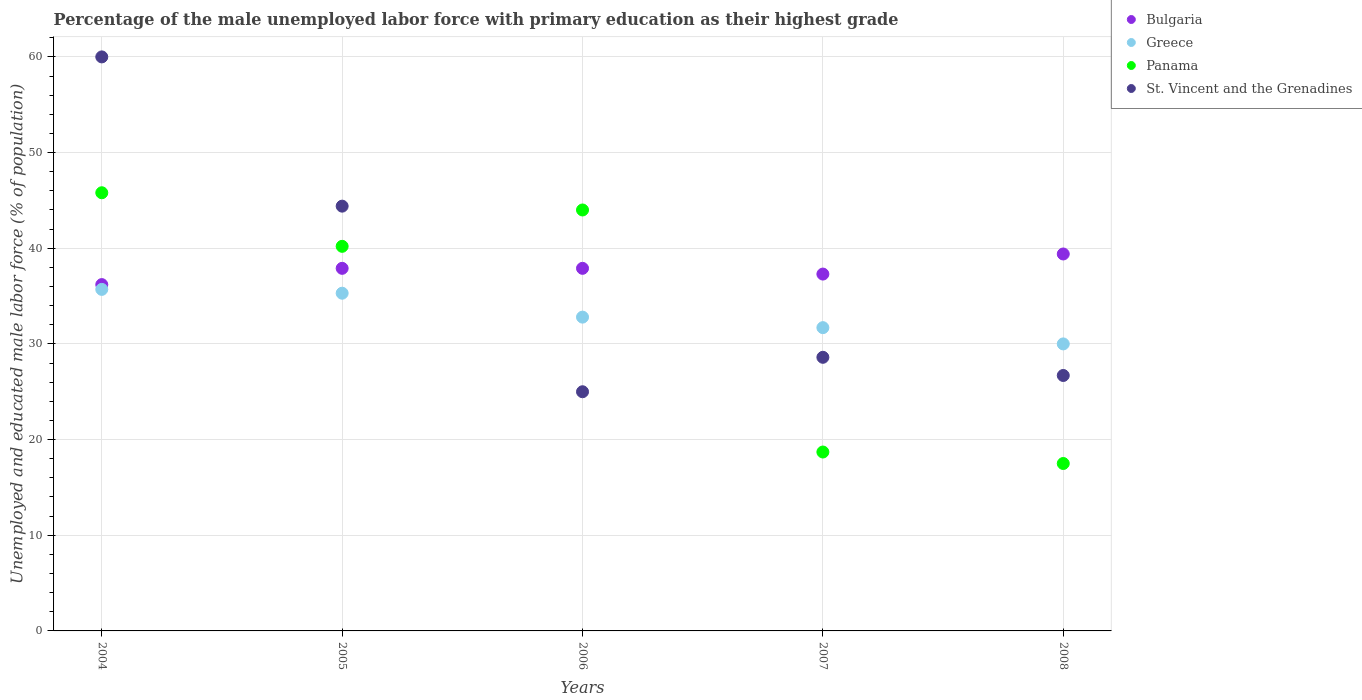How many different coloured dotlines are there?
Your answer should be very brief. 4. Is the number of dotlines equal to the number of legend labels?
Your answer should be compact. Yes. What is the percentage of the unemployed male labor force with primary education in Greece in 2006?
Your answer should be compact. 32.8. Across all years, what is the maximum percentage of the unemployed male labor force with primary education in Panama?
Provide a succinct answer. 45.8. Across all years, what is the minimum percentage of the unemployed male labor force with primary education in St. Vincent and the Grenadines?
Offer a terse response. 25. In which year was the percentage of the unemployed male labor force with primary education in Greece maximum?
Provide a short and direct response. 2004. In which year was the percentage of the unemployed male labor force with primary education in Greece minimum?
Make the answer very short. 2008. What is the total percentage of the unemployed male labor force with primary education in Greece in the graph?
Your answer should be compact. 165.5. What is the difference between the percentage of the unemployed male labor force with primary education in Panama in 2005 and that in 2006?
Give a very brief answer. -3.8. What is the average percentage of the unemployed male labor force with primary education in Greece per year?
Provide a succinct answer. 33.1. In the year 2007, what is the difference between the percentage of the unemployed male labor force with primary education in Bulgaria and percentage of the unemployed male labor force with primary education in Panama?
Provide a succinct answer. 18.6. What is the ratio of the percentage of the unemployed male labor force with primary education in Panama in 2006 to that in 2007?
Ensure brevity in your answer.  2.35. Is the percentage of the unemployed male labor force with primary education in Greece in 2004 less than that in 2005?
Keep it short and to the point. No. What is the difference between the highest and the second highest percentage of the unemployed male labor force with primary education in St. Vincent and the Grenadines?
Provide a short and direct response. 15.6. What is the difference between the highest and the lowest percentage of the unemployed male labor force with primary education in Panama?
Make the answer very short. 28.3. Is it the case that in every year, the sum of the percentage of the unemployed male labor force with primary education in Greece and percentage of the unemployed male labor force with primary education in St. Vincent and the Grenadines  is greater than the sum of percentage of the unemployed male labor force with primary education in Bulgaria and percentage of the unemployed male labor force with primary education in Panama?
Make the answer very short. No. Is the percentage of the unemployed male labor force with primary education in Bulgaria strictly less than the percentage of the unemployed male labor force with primary education in Greece over the years?
Keep it short and to the point. No. How many dotlines are there?
Make the answer very short. 4. How many years are there in the graph?
Keep it short and to the point. 5. Are the values on the major ticks of Y-axis written in scientific E-notation?
Offer a very short reply. No. Where does the legend appear in the graph?
Provide a succinct answer. Top right. How are the legend labels stacked?
Provide a short and direct response. Vertical. What is the title of the graph?
Make the answer very short. Percentage of the male unemployed labor force with primary education as their highest grade. Does "Togo" appear as one of the legend labels in the graph?
Your answer should be very brief. No. What is the label or title of the Y-axis?
Your response must be concise. Unemployed and educated male labor force (% of population). What is the Unemployed and educated male labor force (% of population) in Bulgaria in 2004?
Provide a short and direct response. 36.2. What is the Unemployed and educated male labor force (% of population) in Greece in 2004?
Your answer should be compact. 35.7. What is the Unemployed and educated male labor force (% of population) in Panama in 2004?
Make the answer very short. 45.8. What is the Unemployed and educated male labor force (% of population) in St. Vincent and the Grenadines in 2004?
Give a very brief answer. 60. What is the Unemployed and educated male labor force (% of population) in Bulgaria in 2005?
Your answer should be very brief. 37.9. What is the Unemployed and educated male labor force (% of population) of Greece in 2005?
Ensure brevity in your answer.  35.3. What is the Unemployed and educated male labor force (% of population) of Panama in 2005?
Your answer should be very brief. 40.2. What is the Unemployed and educated male labor force (% of population) in St. Vincent and the Grenadines in 2005?
Keep it short and to the point. 44.4. What is the Unemployed and educated male labor force (% of population) in Bulgaria in 2006?
Offer a very short reply. 37.9. What is the Unemployed and educated male labor force (% of population) of Greece in 2006?
Provide a short and direct response. 32.8. What is the Unemployed and educated male labor force (% of population) in Panama in 2006?
Offer a terse response. 44. What is the Unemployed and educated male labor force (% of population) in St. Vincent and the Grenadines in 2006?
Ensure brevity in your answer.  25. What is the Unemployed and educated male labor force (% of population) of Bulgaria in 2007?
Keep it short and to the point. 37.3. What is the Unemployed and educated male labor force (% of population) of Greece in 2007?
Make the answer very short. 31.7. What is the Unemployed and educated male labor force (% of population) in Panama in 2007?
Offer a very short reply. 18.7. What is the Unemployed and educated male labor force (% of population) of St. Vincent and the Grenadines in 2007?
Ensure brevity in your answer.  28.6. What is the Unemployed and educated male labor force (% of population) of Bulgaria in 2008?
Provide a succinct answer. 39.4. What is the Unemployed and educated male labor force (% of population) of Greece in 2008?
Offer a terse response. 30. What is the Unemployed and educated male labor force (% of population) of St. Vincent and the Grenadines in 2008?
Make the answer very short. 26.7. Across all years, what is the maximum Unemployed and educated male labor force (% of population) in Bulgaria?
Provide a short and direct response. 39.4. Across all years, what is the maximum Unemployed and educated male labor force (% of population) of Greece?
Make the answer very short. 35.7. Across all years, what is the maximum Unemployed and educated male labor force (% of population) in Panama?
Offer a terse response. 45.8. Across all years, what is the minimum Unemployed and educated male labor force (% of population) of Bulgaria?
Offer a terse response. 36.2. What is the total Unemployed and educated male labor force (% of population) in Bulgaria in the graph?
Provide a short and direct response. 188.7. What is the total Unemployed and educated male labor force (% of population) in Greece in the graph?
Your response must be concise. 165.5. What is the total Unemployed and educated male labor force (% of population) of Panama in the graph?
Make the answer very short. 166.2. What is the total Unemployed and educated male labor force (% of population) in St. Vincent and the Grenadines in the graph?
Keep it short and to the point. 184.7. What is the difference between the Unemployed and educated male labor force (% of population) in Bulgaria in 2004 and that in 2005?
Offer a terse response. -1.7. What is the difference between the Unemployed and educated male labor force (% of population) in Panama in 2004 and that in 2005?
Offer a very short reply. 5.6. What is the difference between the Unemployed and educated male labor force (% of population) of St. Vincent and the Grenadines in 2004 and that in 2005?
Ensure brevity in your answer.  15.6. What is the difference between the Unemployed and educated male labor force (% of population) of Bulgaria in 2004 and that in 2006?
Keep it short and to the point. -1.7. What is the difference between the Unemployed and educated male labor force (% of population) of Greece in 2004 and that in 2006?
Make the answer very short. 2.9. What is the difference between the Unemployed and educated male labor force (% of population) of Panama in 2004 and that in 2006?
Provide a succinct answer. 1.8. What is the difference between the Unemployed and educated male labor force (% of population) in St. Vincent and the Grenadines in 2004 and that in 2006?
Make the answer very short. 35. What is the difference between the Unemployed and educated male labor force (% of population) of Bulgaria in 2004 and that in 2007?
Make the answer very short. -1.1. What is the difference between the Unemployed and educated male labor force (% of population) of Panama in 2004 and that in 2007?
Your response must be concise. 27.1. What is the difference between the Unemployed and educated male labor force (% of population) of St. Vincent and the Grenadines in 2004 and that in 2007?
Give a very brief answer. 31.4. What is the difference between the Unemployed and educated male labor force (% of population) of Bulgaria in 2004 and that in 2008?
Make the answer very short. -3.2. What is the difference between the Unemployed and educated male labor force (% of population) in Panama in 2004 and that in 2008?
Your answer should be very brief. 28.3. What is the difference between the Unemployed and educated male labor force (% of population) in St. Vincent and the Grenadines in 2004 and that in 2008?
Provide a succinct answer. 33.3. What is the difference between the Unemployed and educated male labor force (% of population) in Bulgaria in 2005 and that in 2006?
Your response must be concise. 0. What is the difference between the Unemployed and educated male labor force (% of population) of Greece in 2005 and that in 2006?
Offer a terse response. 2.5. What is the difference between the Unemployed and educated male labor force (% of population) in Panama in 2005 and that in 2006?
Offer a terse response. -3.8. What is the difference between the Unemployed and educated male labor force (% of population) of St. Vincent and the Grenadines in 2005 and that in 2006?
Your response must be concise. 19.4. What is the difference between the Unemployed and educated male labor force (% of population) in Bulgaria in 2005 and that in 2007?
Provide a succinct answer. 0.6. What is the difference between the Unemployed and educated male labor force (% of population) of Greece in 2005 and that in 2007?
Your answer should be very brief. 3.6. What is the difference between the Unemployed and educated male labor force (% of population) in St. Vincent and the Grenadines in 2005 and that in 2007?
Keep it short and to the point. 15.8. What is the difference between the Unemployed and educated male labor force (% of population) of Greece in 2005 and that in 2008?
Provide a short and direct response. 5.3. What is the difference between the Unemployed and educated male labor force (% of population) of Panama in 2005 and that in 2008?
Offer a very short reply. 22.7. What is the difference between the Unemployed and educated male labor force (% of population) in Greece in 2006 and that in 2007?
Your response must be concise. 1.1. What is the difference between the Unemployed and educated male labor force (% of population) in Panama in 2006 and that in 2007?
Your answer should be compact. 25.3. What is the difference between the Unemployed and educated male labor force (% of population) of St. Vincent and the Grenadines in 2006 and that in 2008?
Your response must be concise. -1.7. What is the difference between the Unemployed and educated male labor force (% of population) of Bulgaria in 2007 and that in 2008?
Offer a very short reply. -2.1. What is the difference between the Unemployed and educated male labor force (% of population) of Greece in 2007 and that in 2008?
Offer a terse response. 1.7. What is the difference between the Unemployed and educated male labor force (% of population) of St. Vincent and the Grenadines in 2007 and that in 2008?
Make the answer very short. 1.9. What is the difference between the Unemployed and educated male labor force (% of population) in Bulgaria in 2004 and the Unemployed and educated male labor force (% of population) in Panama in 2005?
Give a very brief answer. -4. What is the difference between the Unemployed and educated male labor force (% of population) in Panama in 2004 and the Unemployed and educated male labor force (% of population) in St. Vincent and the Grenadines in 2005?
Your answer should be very brief. 1.4. What is the difference between the Unemployed and educated male labor force (% of population) in Bulgaria in 2004 and the Unemployed and educated male labor force (% of population) in Greece in 2006?
Your answer should be compact. 3.4. What is the difference between the Unemployed and educated male labor force (% of population) of Bulgaria in 2004 and the Unemployed and educated male labor force (% of population) of Panama in 2006?
Your response must be concise. -7.8. What is the difference between the Unemployed and educated male labor force (% of population) in Greece in 2004 and the Unemployed and educated male labor force (% of population) in St. Vincent and the Grenadines in 2006?
Keep it short and to the point. 10.7. What is the difference between the Unemployed and educated male labor force (% of population) of Panama in 2004 and the Unemployed and educated male labor force (% of population) of St. Vincent and the Grenadines in 2006?
Provide a short and direct response. 20.8. What is the difference between the Unemployed and educated male labor force (% of population) in Bulgaria in 2004 and the Unemployed and educated male labor force (% of population) in Greece in 2007?
Offer a terse response. 4.5. What is the difference between the Unemployed and educated male labor force (% of population) in Bulgaria in 2004 and the Unemployed and educated male labor force (% of population) in Panama in 2007?
Give a very brief answer. 17.5. What is the difference between the Unemployed and educated male labor force (% of population) of Greece in 2004 and the Unemployed and educated male labor force (% of population) of St. Vincent and the Grenadines in 2007?
Provide a short and direct response. 7.1. What is the difference between the Unemployed and educated male labor force (% of population) in Panama in 2004 and the Unemployed and educated male labor force (% of population) in St. Vincent and the Grenadines in 2007?
Provide a short and direct response. 17.2. What is the difference between the Unemployed and educated male labor force (% of population) of Bulgaria in 2004 and the Unemployed and educated male labor force (% of population) of Greece in 2008?
Provide a short and direct response. 6.2. What is the difference between the Unemployed and educated male labor force (% of population) of Greece in 2004 and the Unemployed and educated male labor force (% of population) of Panama in 2008?
Provide a succinct answer. 18.2. What is the difference between the Unemployed and educated male labor force (% of population) in Panama in 2004 and the Unemployed and educated male labor force (% of population) in St. Vincent and the Grenadines in 2008?
Give a very brief answer. 19.1. What is the difference between the Unemployed and educated male labor force (% of population) of Bulgaria in 2005 and the Unemployed and educated male labor force (% of population) of Greece in 2006?
Provide a succinct answer. 5.1. What is the difference between the Unemployed and educated male labor force (% of population) of Bulgaria in 2005 and the Unemployed and educated male labor force (% of population) of St. Vincent and the Grenadines in 2006?
Offer a very short reply. 12.9. What is the difference between the Unemployed and educated male labor force (% of population) of Greece in 2005 and the Unemployed and educated male labor force (% of population) of Panama in 2006?
Provide a succinct answer. -8.7. What is the difference between the Unemployed and educated male labor force (% of population) in Greece in 2005 and the Unemployed and educated male labor force (% of population) in St. Vincent and the Grenadines in 2006?
Make the answer very short. 10.3. What is the difference between the Unemployed and educated male labor force (% of population) in Bulgaria in 2005 and the Unemployed and educated male labor force (% of population) in Panama in 2007?
Offer a terse response. 19.2. What is the difference between the Unemployed and educated male labor force (% of population) in Bulgaria in 2005 and the Unemployed and educated male labor force (% of population) in St. Vincent and the Grenadines in 2007?
Provide a succinct answer. 9.3. What is the difference between the Unemployed and educated male labor force (% of population) of Panama in 2005 and the Unemployed and educated male labor force (% of population) of St. Vincent and the Grenadines in 2007?
Give a very brief answer. 11.6. What is the difference between the Unemployed and educated male labor force (% of population) of Bulgaria in 2005 and the Unemployed and educated male labor force (% of population) of Greece in 2008?
Your answer should be compact. 7.9. What is the difference between the Unemployed and educated male labor force (% of population) of Bulgaria in 2005 and the Unemployed and educated male labor force (% of population) of Panama in 2008?
Ensure brevity in your answer.  20.4. What is the difference between the Unemployed and educated male labor force (% of population) in Bulgaria in 2005 and the Unemployed and educated male labor force (% of population) in St. Vincent and the Grenadines in 2008?
Your answer should be compact. 11.2. What is the difference between the Unemployed and educated male labor force (% of population) in Greece in 2005 and the Unemployed and educated male labor force (% of population) in Panama in 2008?
Your answer should be very brief. 17.8. What is the difference between the Unemployed and educated male labor force (% of population) of Greece in 2005 and the Unemployed and educated male labor force (% of population) of St. Vincent and the Grenadines in 2008?
Your response must be concise. 8.6. What is the difference between the Unemployed and educated male labor force (% of population) in Panama in 2005 and the Unemployed and educated male labor force (% of population) in St. Vincent and the Grenadines in 2008?
Give a very brief answer. 13.5. What is the difference between the Unemployed and educated male labor force (% of population) in Bulgaria in 2006 and the Unemployed and educated male labor force (% of population) in Greece in 2007?
Provide a succinct answer. 6.2. What is the difference between the Unemployed and educated male labor force (% of population) in Bulgaria in 2006 and the Unemployed and educated male labor force (% of population) in Panama in 2007?
Provide a short and direct response. 19.2. What is the difference between the Unemployed and educated male labor force (% of population) of Bulgaria in 2006 and the Unemployed and educated male labor force (% of population) of St. Vincent and the Grenadines in 2007?
Ensure brevity in your answer.  9.3. What is the difference between the Unemployed and educated male labor force (% of population) of Greece in 2006 and the Unemployed and educated male labor force (% of population) of Panama in 2007?
Your answer should be compact. 14.1. What is the difference between the Unemployed and educated male labor force (% of population) of Bulgaria in 2006 and the Unemployed and educated male labor force (% of population) of Greece in 2008?
Offer a very short reply. 7.9. What is the difference between the Unemployed and educated male labor force (% of population) in Bulgaria in 2006 and the Unemployed and educated male labor force (% of population) in Panama in 2008?
Give a very brief answer. 20.4. What is the difference between the Unemployed and educated male labor force (% of population) in Bulgaria in 2006 and the Unemployed and educated male labor force (% of population) in St. Vincent and the Grenadines in 2008?
Ensure brevity in your answer.  11.2. What is the difference between the Unemployed and educated male labor force (% of population) of Greece in 2006 and the Unemployed and educated male labor force (% of population) of St. Vincent and the Grenadines in 2008?
Give a very brief answer. 6.1. What is the difference between the Unemployed and educated male labor force (% of population) of Panama in 2006 and the Unemployed and educated male labor force (% of population) of St. Vincent and the Grenadines in 2008?
Your answer should be compact. 17.3. What is the difference between the Unemployed and educated male labor force (% of population) of Bulgaria in 2007 and the Unemployed and educated male labor force (% of population) of Greece in 2008?
Make the answer very short. 7.3. What is the difference between the Unemployed and educated male labor force (% of population) in Bulgaria in 2007 and the Unemployed and educated male labor force (% of population) in Panama in 2008?
Ensure brevity in your answer.  19.8. What is the average Unemployed and educated male labor force (% of population) of Bulgaria per year?
Provide a short and direct response. 37.74. What is the average Unemployed and educated male labor force (% of population) of Greece per year?
Make the answer very short. 33.1. What is the average Unemployed and educated male labor force (% of population) in Panama per year?
Provide a short and direct response. 33.24. What is the average Unemployed and educated male labor force (% of population) of St. Vincent and the Grenadines per year?
Make the answer very short. 36.94. In the year 2004, what is the difference between the Unemployed and educated male labor force (% of population) in Bulgaria and Unemployed and educated male labor force (% of population) in St. Vincent and the Grenadines?
Keep it short and to the point. -23.8. In the year 2004, what is the difference between the Unemployed and educated male labor force (% of population) of Greece and Unemployed and educated male labor force (% of population) of St. Vincent and the Grenadines?
Offer a very short reply. -24.3. In the year 2004, what is the difference between the Unemployed and educated male labor force (% of population) of Panama and Unemployed and educated male labor force (% of population) of St. Vincent and the Grenadines?
Make the answer very short. -14.2. In the year 2005, what is the difference between the Unemployed and educated male labor force (% of population) of Bulgaria and Unemployed and educated male labor force (% of population) of Greece?
Provide a succinct answer. 2.6. In the year 2005, what is the difference between the Unemployed and educated male labor force (% of population) in Bulgaria and Unemployed and educated male labor force (% of population) in St. Vincent and the Grenadines?
Give a very brief answer. -6.5. In the year 2005, what is the difference between the Unemployed and educated male labor force (% of population) of Greece and Unemployed and educated male labor force (% of population) of St. Vincent and the Grenadines?
Offer a very short reply. -9.1. In the year 2005, what is the difference between the Unemployed and educated male labor force (% of population) of Panama and Unemployed and educated male labor force (% of population) of St. Vincent and the Grenadines?
Give a very brief answer. -4.2. In the year 2006, what is the difference between the Unemployed and educated male labor force (% of population) in Bulgaria and Unemployed and educated male labor force (% of population) in Greece?
Provide a succinct answer. 5.1. In the year 2006, what is the difference between the Unemployed and educated male labor force (% of population) in Bulgaria and Unemployed and educated male labor force (% of population) in Panama?
Offer a terse response. -6.1. In the year 2006, what is the difference between the Unemployed and educated male labor force (% of population) in Bulgaria and Unemployed and educated male labor force (% of population) in St. Vincent and the Grenadines?
Make the answer very short. 12.9. In the year 2006, what is the difference between the Unemployed and educated male labor force (% of population) of Greece and Unemployed and educated male labor force (% of population) of Panama?
Keep it short and to the point. -11.2. In the year 2008, what is the difference between the Unemployed and educated male labor force (% of population) in Bulgaria and Unemployed and educated male labor force (% of population) in Greece?
Ensure brevity in your answer.  9.4. In the year 2008, what is the difference between the Unemployed and educated male labor force (% of population) of Bulgaria and Unemployed and educated male labor force (% of population) of Panama?
Offer a very short reply. 21.9. In the year 2008, what is the difference between the Unemployed and educated male labor force (% of population) of Bulgaria and Unemployed and educated male labor force (% of population) of St. Vincent and the Grenadines?
Your answer should be compact. 12.7. In the year 2008, what is the difference between the Unemployed and educated male labor force (% of population) of Panama and Unemployed and educated male labor force (% of population) of St. Vincent and the Grenadines?
Offer a very short reply. -9.2. What is the ratio of the Unemployed and educated male labor force (% of population) of Bulgaria in 2004 to that in 2005?
Provide a succinct answer. 0.96. What is the ratio of the Unemployed and educated male labor force (% of population) in Greece in 2004 to that in 2005?
Ensure brevity in your answer.  1.01. What is the ratio of the Unemployed and educated male labor force (% of population) of Panama in 2004 to that in 2005?
Your answer should be compact. 1.14. What is the ratio of the Unemployed and educated male labor force (% of population) in St. Vincent and the Grenadines in 2004 to that in 2005?
Make the answer very short. 1.35. What is the ratio of the Unemployed and educated male labor force (% of population) of Bulgaria in 2004 to that in 2006?
Provide a succinct answer. 0.96. What is the ratio of the Unemployed and educated male labor force (% of population) in Greece in 2004 to that in 2006?
Ensure brevity in your answer.  1.09. What is the ratio of the Unemployed and educated male labor force (% of population) of Panama in 2004 to that in 2006?
Keep it short and to the point. 1.04. What is the ratio of the Unemployed and educated male labor force (% of population) in St. Vincent and the Grenadines in 2004 to that in 2006?
Make the answer very short. 2.4. What is the ratio of the Unemployed and educated male labor force (% of population) of Bulgaria in 2004 to that in 2007?
Your response must be concise. 0.97. What is the ratio of the Unemployed and educated male labor force (% of population) of Greece in 2004 to that in 2007?
Offer a terse response. 1.13. What is the ratio of the Unemployed and educated male labor force (% of population) in Panama in 2004 to that in 2007?
Your response must be concise. 2.45. What is the ratio of the Unemployed and educated male labor force (% of population) of St. Vincent and the Grenadines in 2004 to that in 2007?
Your response must be concise. 2.1. What is the ratio of the Unemployed and educated male labor force (% of population) of Bulgaria in 2004 to that in 2008?
Keep it short and to the point. 0.92. What is the ratio of the Unemployed and educated male labor force (% of population) in Greece in 2004 to that in 2008?
Your answer should be very brief. 1.19. What is the ratio of the Unemployed and educated male labor force (% of population) in Panama in 2004 to that in 2008?
Ensure brevity in your answer.  2.62. What is the ratio of the Unemployed and educated male labor force (% of population) in St. Vincent and the Grenadines in 2004 to that in 2008?
Keep it short and to the point. 2.25. What is the ratio of the Unemployed and educated male labor force (% of population) of Bulgaria in 2005 to that in 2006?
Your answer should be compact. 1. What is the ratio of the Unemployed and educated male labor force (% of population) in Greece in 2005 to that in 2006?
Your answer should be very brief. 1.08. What is the ratio of the Unemployed and educated male labor force (% of population) in Panama in 2005 to that in 2006?
Give a very brief answer. 0.91. What is the ratio of the Unemployed and educated male labor force (% of population) of St. Vincent and the Grenadines in 2005 to that in 2006?
Offer a terse response. 1.78. What is the ratio of the Unemployed and educated male labor force (% of population) in Bulgaria in 2005 to that in 2007?
Your answer should be very brief. 1.02. What is the ratio of the Unemployed and educated male labor force (% of population) in Greece in 2005 to that in 2007?
Your response must be concise. 1.11. What is the ratio of the Unemployed and educated male labor force (% of population) of Panama in 2005 to that in 2007?
Offer a terse response. 2.15. What is the ratio of the Unemployed and educated male labor force (% of population) in St. Vincent and the Grenadines in 2005 to that in 2007?
Ensure brevity in your answer.  1.55. What is the ratio of the Unemployed and educated male labor force (% of population) of Bulgaria in 2005 to that in 2008?
Your answer should be compact. 0.96. What is the ratio of the Unemployed and educated male labor force (% of population) of Greece in 2005 to that in 2008?
Make the answer very short. 1.18. What is the ratio of the Unemployed and educated male labor force (% of population) of Panama in 2005 to that in 2008?
Your answer should be very brief. 2.3. What is the ratio of the Unemployed and educated male labor force (% of population) of St. Vincent and the Grenadines in 2005 to that in 2008?
Offer a terse response. 1.66. What is the ratio of the Unemployed and educated male labor force (% of population) of Bulgaria in 2006 to that in 2007?
Offer a very short reply. 1.02. What is the ratio of the Unemployed and educated male labor force (% of population) in Greece in 2006 to that in 2007?
Your response must be concise. 1.03. What is the ratio of the Unemployed and educated male labor force (% of population) in Panama in 2006 to that in 2007?
Offer a terse response. 2.35. What is the ratio of the Unemployed and educated male labor force (% of population) of St. Vincent and the Grenadines in 2006 to that in 2007?
Your answer should be compact. 0.87. What is the ratio of the Unemployed and educated male labor force (% of population) of Bulgaria in 2006 to that in 2008?
Make the answer very short. 0.96. What is the ratio of the Unemployed and educated male labor force (% of population) in Greece in 2006 to that in 2008?
Your answer should be compact. 1.09. What is the ratio of the Unemployed and educated male labor force (% of population) in Panama in 2006 to that in 2008?
Your answer should be compact. 2.51. What is the ratio of the Unemployed and educated male labor force (% of population) of St. Vincent and the Grenadines in 2006 to that in 2008?
Your answer should be compact. 0.94. What is the ratio of the Unemployed and educated male labor force (% of population) of Bulgaria in 2007 to that in 2008?
Your answer should be compact. 0.95. What is the ratio of the Unemployed and educated male labor force (% of population) in Greece in 2007 to that in 2008?
Provide a short and direct response. 1.06. What is the ratio of the Unemployed and educated male labor force (% of population) of Panama in 2007 to that in 2008?
Provide a succinct answer. 1.07. What is the ratio of the Unemployed and educated male labor force (% of population) in St. Vincent and the Grenadines in 2007 to that in 2008?
Your response must be concise. 1.07. What is the difference between the highest and the lowest Unemployed and educated male labor force (% of population) in Bulgaria?
Your response must be concise. 3.2. What is the difference between the highest and the lowest Unemployed and educated male labor force (% of population) of Panama?
Your response must be concise. 28.3. 